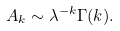Convert formula to latex. <formula><loc_0><loc_0><loc_500><loc_500>A _ { k } \sim \lambda ^ { - k } \Gamma ( k ) .</formula> 